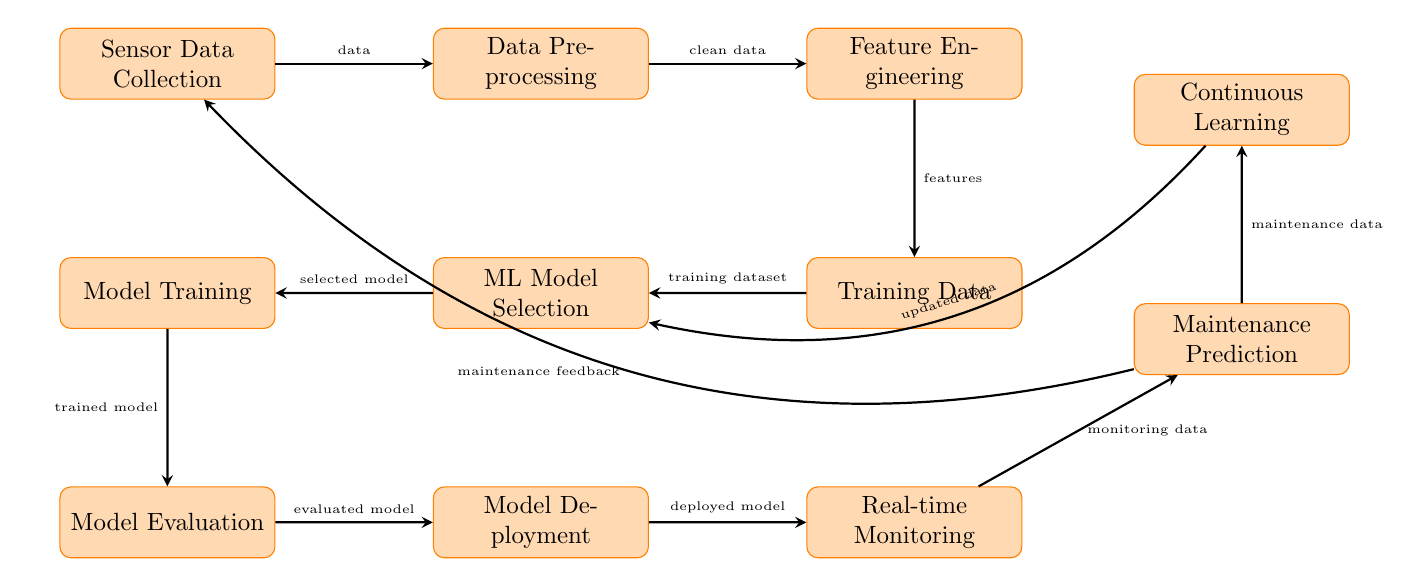What is the first step in the process? The first step in the process is represented by the node labeled "Sensor Data Collection," located at the beginning of the sequence.
Answer: Sensor Data Collection What node comes after "Data Preprocessing"? "Feature Engineering" is the node that follows "Data Preprocessing" in the flow.
Answer: Feature Engineering How many nodes are there in total? Counting all the distinct nodes in the diagram, there are ten individual nodes involved in the process.
Answer: 10 What is the output of "Model Evaluation"? The output from "Model Evaluation" is the "evaluated model," which shows that after the evaluation takes place, this particular output is generated.
Answer: evaluated model Which two nodes are connected to "Maintenance Prediction"? "Real-time Monitoring" flows into "Maintenance Prediction," and "Continuous Learning" also receives maintenance data from "Maintenance Prediction," indicating a dual connection to this node.
Answer: Real-time Monitoring and Continuous Learning What feedback does "Maintenance Prediction" provide? "Maintenance Prediction" offers "maintenance feedback" that loops back to "Sensor Data Collection," implying it influences the initial data collection phase.
Answer: maintenance feedback What is the role of "Continuous Learning" in the diagram? "Continuous Learning" updates the learned models after receiving new maintenance data, indicating its role is to refine and improve the predictive capabilities continually.
Answer: updated data Which node is directly related to "Model Selection"? "Training Data" is the node that directly comes after "Model Selection," meaning the model selection influences the training phase that follows.
Answer: Training Data What is the last node in the process? The final step in the diagram is "Real-time Monitoring," making it the last node in the flow of operations.
Answer: Real-time Monitoring 